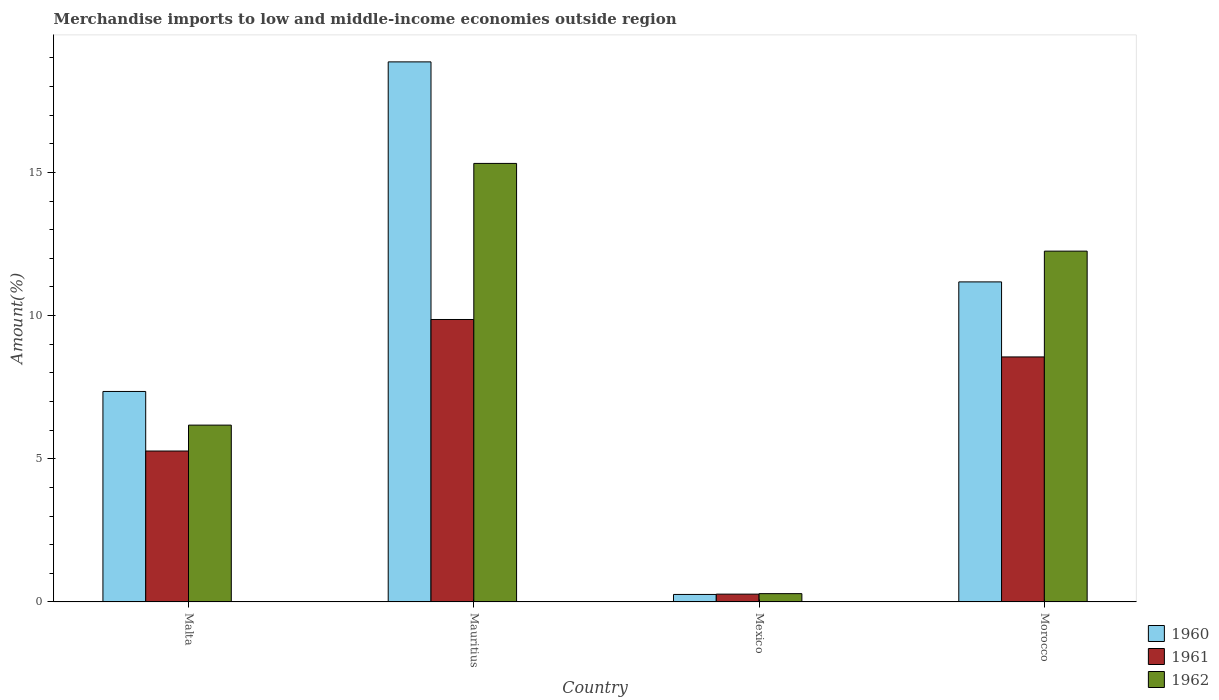How many different coloured bars are there?
Offer a very short reply. 3. How many groups of bars are there?
Your response must be concise. 4. Are the number of bars on each tick of the X-axis equal?
Provide a short and direct response. Yes. How many bars are there on the 2nd tick from the left?
Your answer should be compact. 3. How many bars are there on the 3rd tick from the right?
Give a very brief answer. 3. What is the label of the 4th group of bars from the left?
Your answer should be very brief. Morocco. What is the percentage of amount earned from merchandise imports in 1960 in Malta?
Offer a very short reply. 7.35. Across all countries, what is the maximum percentage of amount earned from merchandise imports in 1961?
Offer a terse response. 9.86. Across all countries, what is the minimum percentage of amount earned from merchandise imports in 1961?
Your answer should be very brief. 0.27. In which country was the percentage of amount earned from merchandise imports in 1961 maximum?
Offer a terse response. Mauritius. What is the total percentage of amount earned from merchandise imports in 1960 in the graph?
Offer a very short reply. 37.65. What is the difference between the percentage of amount earned from merchandise imports in 1961 in Mauritius and that in Mexico?
Offer a terse response. 9.59. What is the difference between the percentage of amount earned from merchandise imports in 1962 in Mauritius and the percentage of amount earned from merchandise imports in 1960 in Malta?
Offer a very short reply. 7.96. What is the average percentage of amount earned from merchandise imports in 1962 per country?
Keep it short and to the point. 8.51. What is the difference between the percentage of amount earned from merchandise imports of/in 1960 and percentage of amount earned from merchandise imports of/in 1961 in Morocco?
Your response must be concise. 2.62. In how many countries, is the percentage of amount earned from merchandise imports in 1961 greater than 5 %?
Provide a succinct answer. 3. What is the ratio of the percentage of amount earned from merchandise imports in 1962 in Mauritius to that in Mexico?
Your response must be concise. 52.86. Is the percentage of amount earned from merchandise imports in 1961 in Mexico less than that in Morocco?
Provide a succinct answer. Yes. Is the difference between the percentage of amount earned from merchandise imports in 1960 in Mauritius and Morocco greater than the difference between the percentage of amount earned from merchandise imports in 1961 in Mauritius and Morocco?
Offer a very short reply. Yes. What is the difference between the highest and the second highest percentage of amount earned from merchandise imports in 1962?
Keep it short and to the point. 6.08. What is the difference between the highest and the lowest percentage of amount earned from merchandise imports in 1962?
Ensure brevity in your answer.  15.02. What does the 3rd bar from the left in Morocco represents?
Ensure brevity in your answer.  1962. How many bars are there?
Give a very brief answer. 12. Are all the bars in the graph horizontal?
Keep it short and to the point. No. What is the difference between two consecutive major ticks on the Y-axis?
Your answer should be compact. 5. Are the values on the major ticks of Y-axis written in scientific E-notation?
Provide a succinct answer. No. Does the graph contain any zero values?
Your answer should be very brief. No. Does the graph contain grids?
Offer a very short reply. No. Where does the legend appear in the graph?
Ensure brevity in your answer.  Bottom right. How are the legend labels stacked?
Your answer should be very brief. Vertical. What is the title of the graph?
Offer a very short reply. Merchandise imports to low and middle-income economies outside region. Does "1985" appear as one of the legend labels in the graph?
Your response must be concise. No. What is the label or title of the Y-axis?
Your response must be concise. Amount(%). What is the Amount(%) in 1960 in Malta?
Offer a terse response. 7.35. What is the Amount(%) of 1961 in Malta?
Provide a succinct answer. 5.27. What is the Amount(%) of 1962 in Malta?
Provide a succinct answer. 6.18. What is the Amount(%) in 1960 in Mauritius?
Provide a succinct answer. 18.86. What is the Amount(%) in 1961 in Mauritius?
Offer a very short reply. 9.86. What is the Amount(%) in 1962 in Mauritius?
Provide a short and direct response. 15.31. What is the Amount(%) in 1960 in Mexico?
Make the answer very short. 0.26. What is the Amount(%) of 1961 in Mexico?
Ensure brevity in your answer.  0.27. What is the Amount(%) in 1962 in Mexico?
Give a very brief answer. 0.29. What is the Amount(%) in 1960 in Morocco?
Provide a succinct answer. 11.18. What is the Amount(%) of 1961 in Morocco?
Your response must be concise. 8.56. What is the Amount(%) in 1962 in Morocco?
Your answer should be very brief. 12.25. Across all countries, what is the maximum Amount(%) of 1960?
Make the answer very short. 18.86. Across all countries, what is the maximum Amount(%) in 1961?
Ensure brevity in your answer.  9.86. Across all countries, what is the maximum Amount(%) in 1962?
Offer a very short reply. 15.31. Across all countries, what is the minimum Amount(%) of 1960?
Provide a short and direct response. 0.26. Across all countries, what is the minimum Amount(%) in 1961?
Offer a terse response. 0.27. Across all countries, what is the minimum Amount(%) in 1962?
Your answer should be very brief. 0.29. What is the total Amount(%) in 1960 in the graph?
Your answer should be compact. 37.65. What is the total Amount(%) in 1961 in the graph?
Offer a terse response. 23.96. What is the total Amount(%) in 1962 in the graph?
Provide a short and direct response. 34.03. What is the difference between the Amount(%) in 1960 in Malta and that in Mauritius?
Ensure brevity in your answer.  -11.51. What is the difference between the Amount(%) in 1961 in Malta and that in Mauritius?
Give a very brief answer. -4.59. What is the difference between the Amount(%) in 1962 in Malta and that in Mauritius?
Ensure brevity in your answer.  -9.14. What is the difference between the Amount(%) of 1960 in Malta and that in Mexico?
Keep it short and to the point. 7.09. What is the difference between the Amount(%) in 1961 in Malta and that in Mexico?
Your answer should be compact. 5. What is the difference between the Amount(%) in 1962 in Malta and that in Mexico?
Make the answer very short. 5.89. What is the difference between the Amount(%) of 1960 in Malta and that in Morocco?
Your response must be concise. -3.83. What is the difference between the Amount(%) in 1961 in Malta and that in Morocco?
Provide a short and direct response. -3.29. What is the difference between the Amount(%) in 1962 in Malta and that in Morocco?
Offer a very short reply. -6.08. What is the difference between the Amount(%) in 1960 in Mauritius and that in Mexico?
Make the answer very short. 18.6. What is the difference between the Amount(%) of 1961 in Mauritius and that in Mexico?
Offer a very short reply. 9.59. What is the difference between the Amount(%) of 1962 in Mauritius and that in Mexico?
Ensure brevity in your answer.  15.02. What is the difference between the Amount(%) in 1960 in Mauritius and that in Morocco?
Provide a short and direct response. 7.68. What is the difference between the Amount(%) of 1961 in Mauritius and that in Morocco?
Provide a short and direct response. 1.31. What is the difference between the Amount(%) in 1962 in Mauritius and that in Morocco?
Your answer should be compact. 3.06. What is the difference between the Amount(%) in 1960 in Mexico and that in Morocco?
Offer a terse response. -10.91. What is the difference between the Amount(%) of 1961 in Mexico and that in Morocco?
Provide a short and direct response. -8.28. What is the difference between the Amount(%) in 1962 in Mexico and that in Morocco?
Provide a succinct answer. -11.96. What is the difference between the Amount(%) in 1960 in Malta and the Amount(%) in 1961 in Mauritius?
Provide a short and direct response. -2.51. What is the difference between the Amount(%) in 1960 in Malta and the Amount(%) in 1962 in Mauritius?
Offer a very short reply. -7.96. What is the difference between the Amount(%) of 1961 in Malta and the Amount(%) of 1962 in Mauritius?
Your response must be concise. -10.04. What is the difference between the Amount(%) in 1960 in Malta and the Amount(%) in 1961 in Mexico?
Provide a succinct answer. 7.08. What is the difference between the Amount(%) in 1960 in Malta and the Amount(%) in 1962 in Mexico?
Make the answer very short. 7.06. What is the difference between the Amount(%) of 1961 in Malta and the Amount(%) of 1962 in Mexico?
Your response must be concise. 4.98. What is the difference between the Amount(%) of 1960 in Malta and the Amount(%) of 1961 in Morocco?
Your response must be concise. -1.21. What is the difference between the Amount(%) in 1960 in Malta and the Amount(%) in 1962 in Morocco?
Provide a short and direct response. -4.9. What is the difference between the Amount(%) of 1961 in Malta and the Amount(%) of 1962 in Morocco?
Ensure brevity in your answer.  -6.98. What is the difference between the Amount(%) in 1960 in Mauritius and the Amount(%) in 1961 in Mexico?
Provide a succinct answer. 18.59. What is the difference between the Amount(%) in 1960 in Mauritius and the Amount(%) in 1962 in Mexico?
Give a very brief answer. 18.57. What is the difference between the Amount(%) of 1961 in Mauritius and the Amount(%) of 1962 in Mexico?
Your answer should be compact. 9.57. What is the difference between the Amount(%) in 1960 in Mauritius and the Amount(%) in 1961 in Morocco?
Offer a terse response. 10.3. What is the difference between the Amount(%) in 1960 in Mauritius and the Amount(%) in 1962 in Morocco?
Offer a very short reply. 6.61. What is the difference between the Amount(%) of 1961 in Mauritius and the Amount(%) of 1962 in Morocco?
Your response must be concise. -2.39. What is the difference between the Amount(%) of 1960 in Mexico and the Amount(%) of 1961 in Morocco?
Offer a very short reply. -8.29. What is the difference between the Amount(%) of 1960 in Mexico and the Amount(%) of 1962 in Morocco?
Offer a very short reply. -11.99. What is the difference between the Amount(%) of 1961 in Mexico and the Amount(%) of 1962 in Morocco?
Offer a very short reply. -11.98. What is the average Amount(%) in 1960 per country?
Your answer should be very brief. 9.41. What is the average Amount(%) of 1961 per country?
Make the answer very short. 5.99. What is the average Amount(%) in 1962 per country?
Give a very brief answer. 8.51. What is the difference between the Amount(%) in 1960 and Amount(%) in 1961 in Malta?
Provide a succinct answer. 2.08. What is the difference between the Amount(%) of 1960 and Amount(%) of 1962 in Malta?
Your answer should be compact. 1.17. What is the difference between the Amount(%) of 1961 and Amount(%) of 1962 in Malta?
Ensure brevity in your answer.  -0.9. What is the difference between the Amount(%) in 1960 and Amount(%) in 1961 in Mauritius?
Offer a very short reply. 9. What is the difference between the Amount(%) of 1960 and Amount(%) of 1962 in Mauritius?
Keep it short and to the point. 3.55. What is the difference between the Amount(%) of 1961 and Amount(%) of 1962 in Mauritius?
Make the answer very short. -5.45. What is the difference between the Amount(%) of 1960 and Amount(%) of 1961 in Mexico?
Your response must be concise. -0.01. What is the difference between the Amount(%) in 1960 and Amount(%) in 1962 in Mexico?
Provide a succinct answer. -0.03. What is the difference between the Amount(%) of 1961 and Amount(%) of 1962 in Mexico?
Ensure brevity in your answer.  -0.02. What is the difference between the Amount(%) of 1960 and Amount(%) of 1961 in Morocco?
Offer a terse response. 2.62. What is the difference between the Amount(%) in 1960 and Amount(%) in 1962 in Morocco?
Provide a succinct answer. -1.07. What is the difference between the Amount(%) in 1961 and Amount(%) in 1962 in Morocco?
Offer a terse response. -3.69. What is the ratio of the Amount(%) in 1960 in Malta to that in Mauritius?
Provide a short and direct response. 0.39. What is the ratio of the Amount(%) of 1961 in Malta to that in Mauritius?
Your answer should be very brief. 0.53. What is the ratio of the Amount(%) of 1962 in Malta to that in Mauritius?
Your answer should be compact. 0.4. What is the ratio of the Amount(%) in 1960 in Malta to that in Mexico?
Provide a short and direct response. 28.05. What is the ratio of the Amount(%) in 1961 in Malta to that in Mexico?
Make the answer very short. 19.32. What is the ratio of the Amount(%) of 1962 in Malta to that in Mexico?
Keep it short and to the point. 21.31. What is the ratio of the Amount(%) of 1960 in Malta to that in Morocco?
Offer a terse response. 0.66. What is the ratio of the Amount(%) of 1961 in Malta to that in Morocco?
Offer a terse response. 0.62. What is the ratio of the Amount(%) in 1962 in Malta to that in Morocco?
Provide a succinct answer. 0.5. What is the ratio of the Amount(%) in 1960 in Mauritius to that in Mexico?
Give a very brief answer. 71.98. What is the ratio of the Amount(%) of 1961 in Mauritius to that in Mexico?
Your answer should be very brief. 36.15. What is the ratio of the Amount(%) of 1962 in Mauritius to that in Mexico?
Provide a short and direct response. 52.86. What is the ratio of the Amount(%) in 1960 in Mauritius to that in Morocco?
Your answer should be very brief. 1.69. What is the ratio of the Amount(%) in 1961 in Mauritius to that in Morocco?
Offer a terse response. 1.15. What is the ratio of the Amount(%) in 1962 in Mauritius to that in Morocco?
Keep it short and to the point. 1.25. What is the ratio of the Amount(%) in 1960 in Mexico to that in Morocco?
Give a very brief answer. 0.02. What is the ratio of the Amount(%) in 1961 in Mexico to that in Morocco?
Make the answer very short. 0.03. What is the ratio of the Amount(%) of 1962 in Mexico to that in Morocco?
Offer a terse response. 0.02. What is the difference between the highest and the second highest Amount(%) of 1960?
Keep it short and to the point. 7.68. What is the difference between the highest and the second highest Amount(%) in 1961?
Your response must be concise. 1.31. What is the difference between the highest and the second highest Amount(%) of 1962?
Offer a terse response. 3.06. What is the difference between the highest and the lowest Amount(%) of 1960?
Your response must be concise. 18.6. What is the difference between the highest and the lowest Amount(%) of 1961?
Offer a terse response. 9.59. What is the difference between the highest and the lowest Amount(%) in 1962?
Provide a succinct answer. 15.02. 